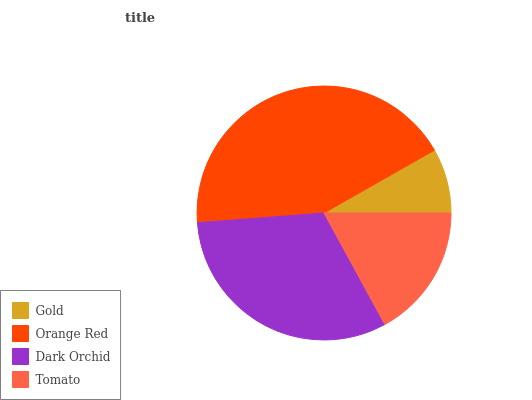Is Gold the minimum?
Answer yes or no. Yes. Is Orange Red the maximum?
Answer yes or no. Yes. Is Dark Orchid the minimum?
Answer yes or no. No. Is Dark Orchid the maximum?
Answer yes or no. No. Is Orange Red greater than Dark Orchid?
Answer yes or no. Yes. Is Dark Orchid less than Orange Red?
Answer yes or no. Yes. Is Dark Orchid greater than Orange Red?
Answer yes or no. No. Is Orange Red less than Dark Orchid?
Answer yes or no. No. Is Dark Orchid the high median?
Answer yes or no. Yes. Is Tomato the low median?
Answer yes or no. Yes. Is Gold the high median?
Answer yes or no. No. Is Orange Red the low median?
Answer yes or no. No. 